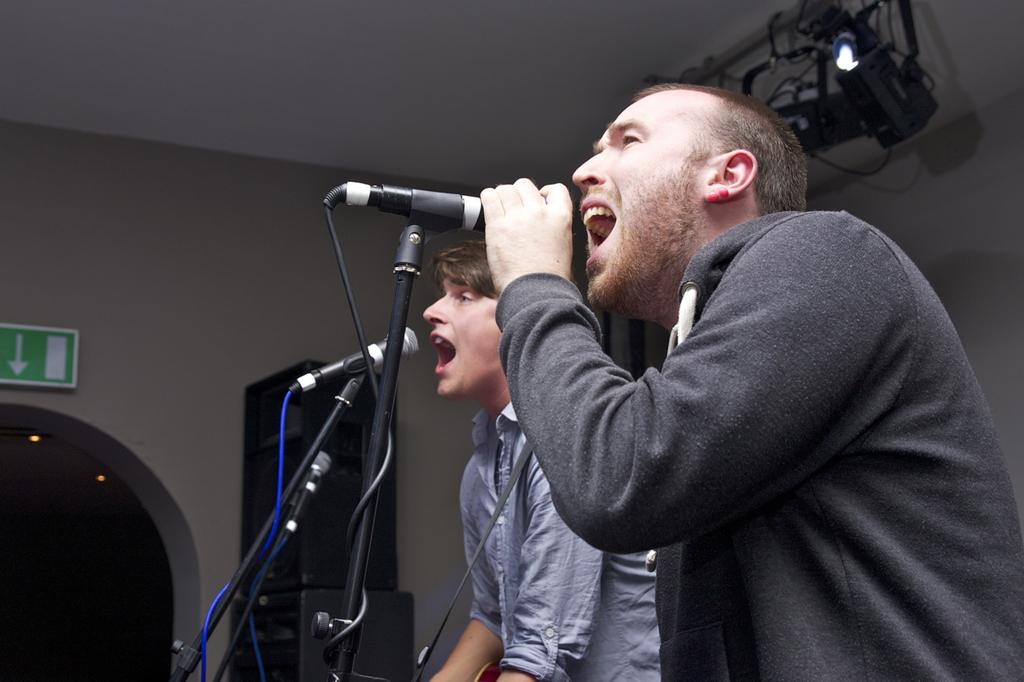What can be seen in the background of the image? There is a wall in the image. How many people are present in the image? There are two people in the image. What are the two people holding? The two people are holding microphones. What are the two people doing with the microphones? The two people are singing a song. Can you see any frogs in the image? No, there are no frogs present in the image. What type of cheese is being used as a prop in the image? There is no cheese present in the image. 